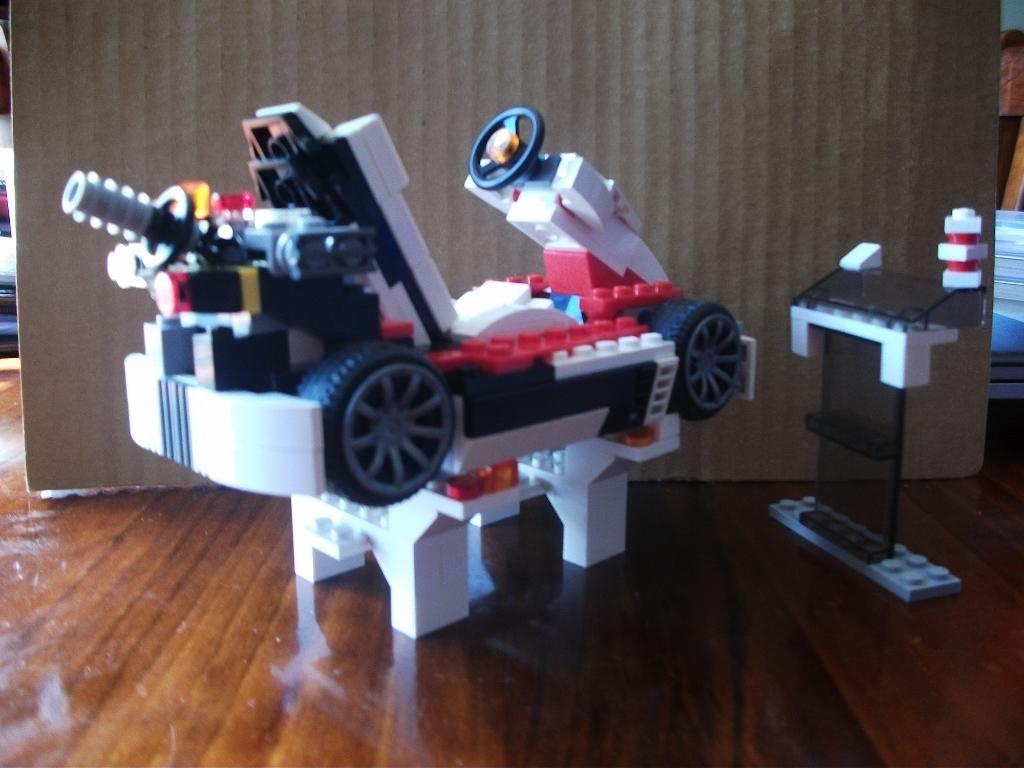What is the main object in the middle of the image? There is a toy in the middle of the image. What can be seen in the background of the image? There is a board in the background of the image. What is visible at the bottom of the image? The floor is visible at the bottom of the image. What other object is present in the image? There is a remote in the image. How does the toy act in the image? The toy is an inanimate object and does not have the ability to act or display emotions. 